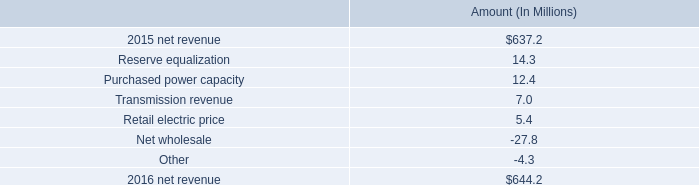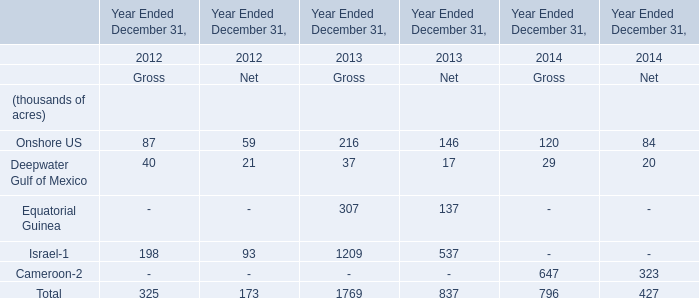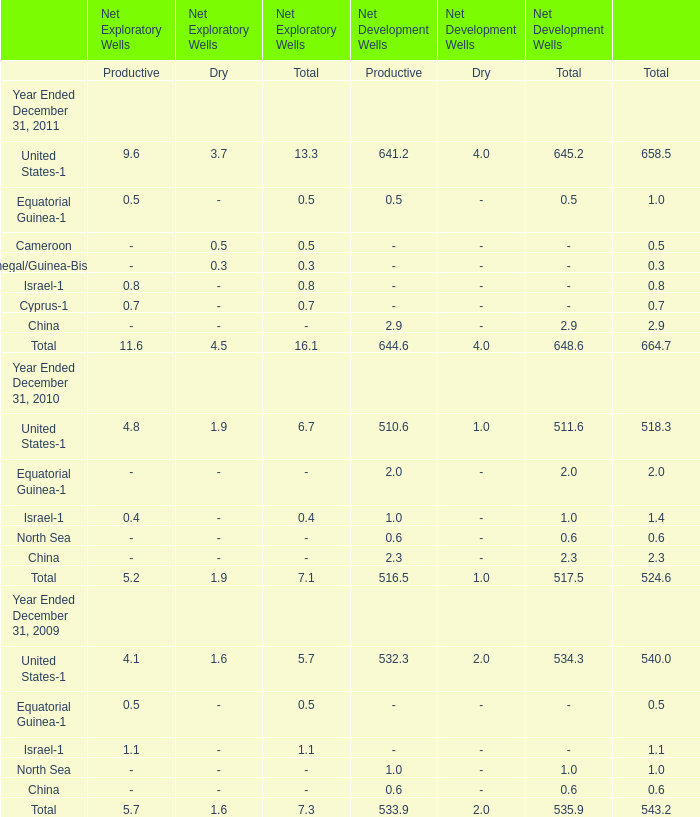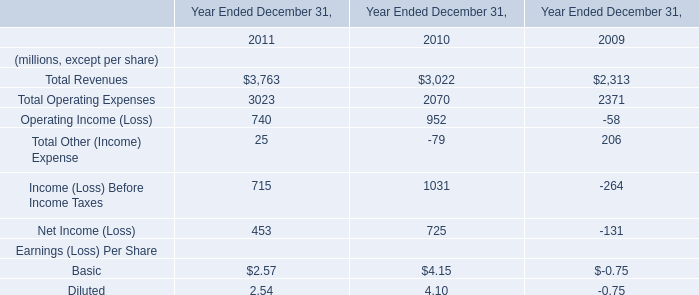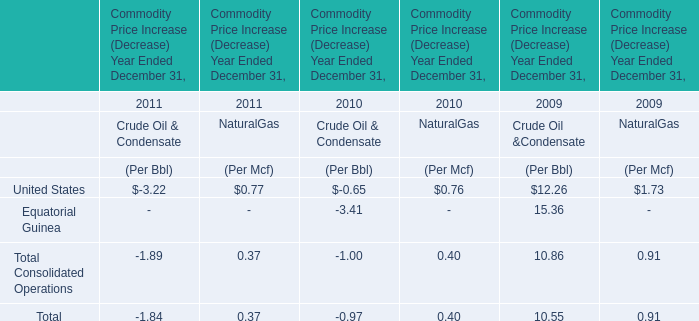What is the growing rate of Equatorial Guinea-1 for Total in the years with the least United States-1 for Total? 
Computations: ((2 - 0.5) / 0.5)
Answer: 3.0. 